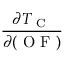<formula> <loc_0><loc_0><loc_500><loc_500>\frac { \partial T _ { C } } { \partial ( O F ) }</formula> 